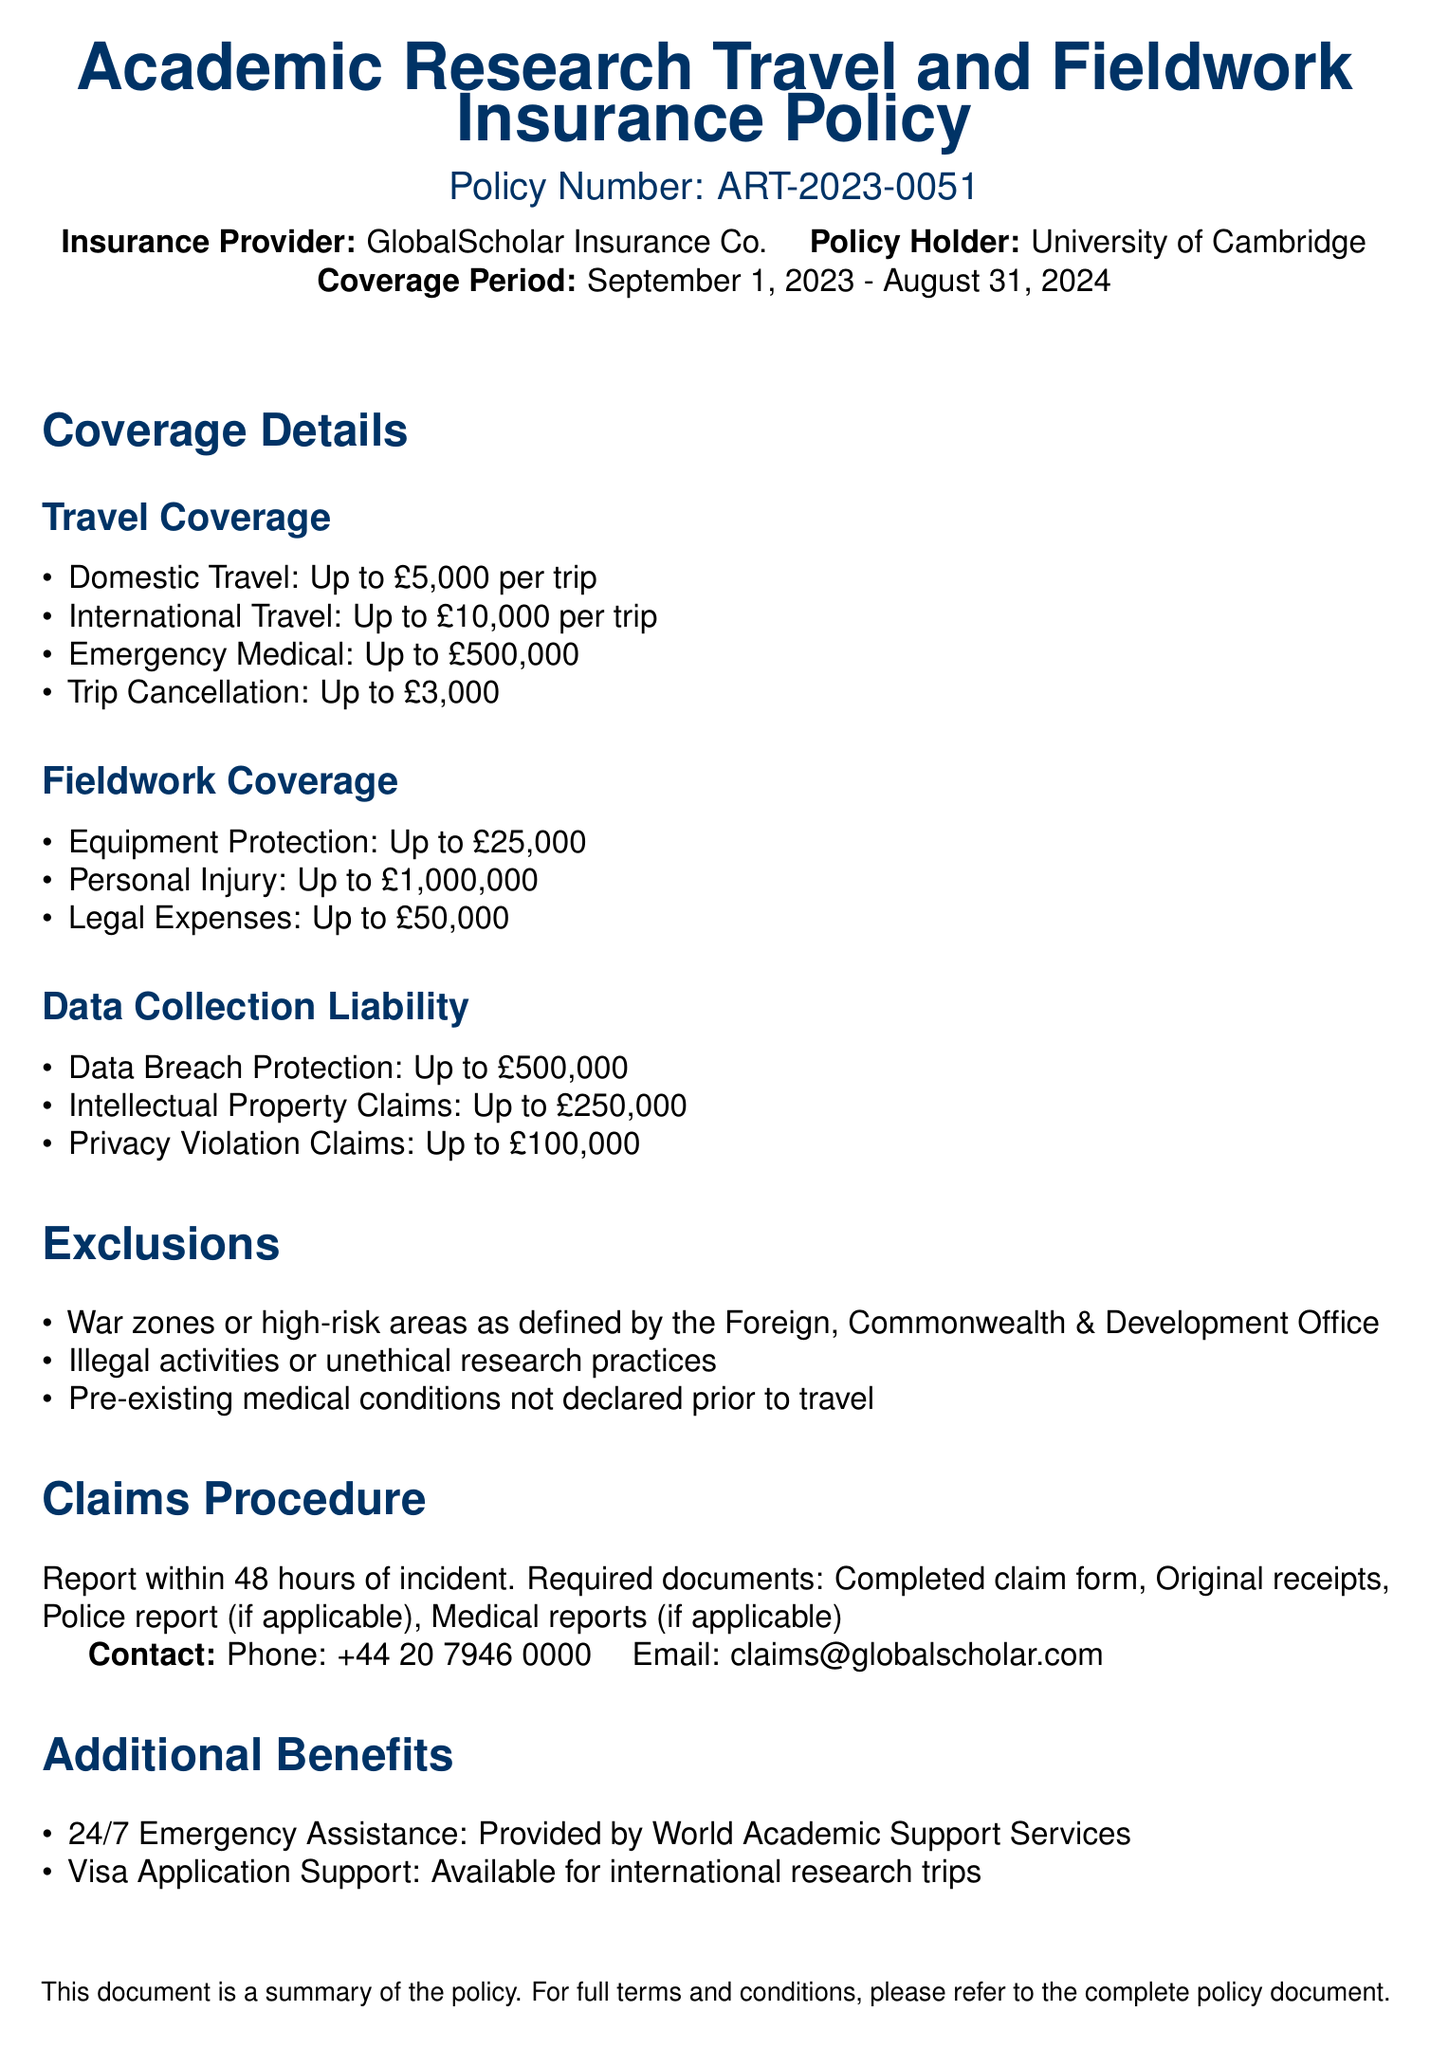What is the policy number? The policy number is explicitly stated in the document as ART-2023-0051.
Answer: ART-2023-0051 What is the coverage period? The coverage period is mentioned as starting from September 1, 2023, to August 31, 2024.
Answer: September 1, 2023 - August 31, 2024 What is the maximum coverage for international travel? The document specifies the maximum coverage for international travel as £10,000 per trip.
Answer: £10,000 What is the coverage for personal injury? The document indicates that personal injury coverage is up to £1,000,000.
Answer: Up to £1,000,000 What is excluded from the policy regarding travel? The document lists wars or high-risk areas as one of the exclusions for the policy.
Answer: War zones or high-risk areas What is the maximum amount for data breach protection? The document states the maximum amount for data breach protection as £500,000.
Answer: £500,000 How long do you have to report an incident? The document specifies that incidents must be reported within 48 hours.
Answer: 48 hours What support is provided for visa applications? The document mentions visa application support as an available benefit for international research trips.
Answer: Visa Application Support Who should be contacted for claims? The document provides a contact phone number and email for claims, specifically claims@globalscholar.com.
Answer: claims@globalscholar.com 